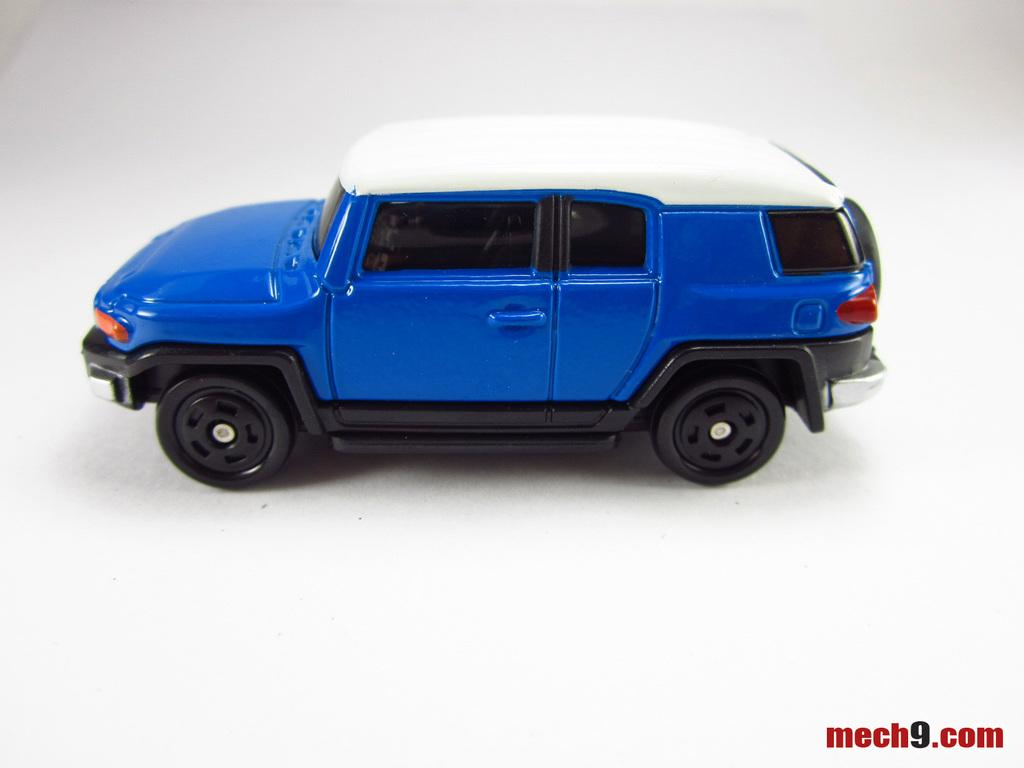What is the main object in the image? There is a toy car in the image. What colors can be seen on the toy car? The toy car is in blue, white, and black colors. Is there any text present in the image? Yes, there is some text in the bottom right side of the image. How many beads are attached to the toy car in the image? There are no beads present on the toy car in the image. Can you tell me how many boys are playing with the toy car in the image? There are no boys present in the image; it only shows the toy car. 